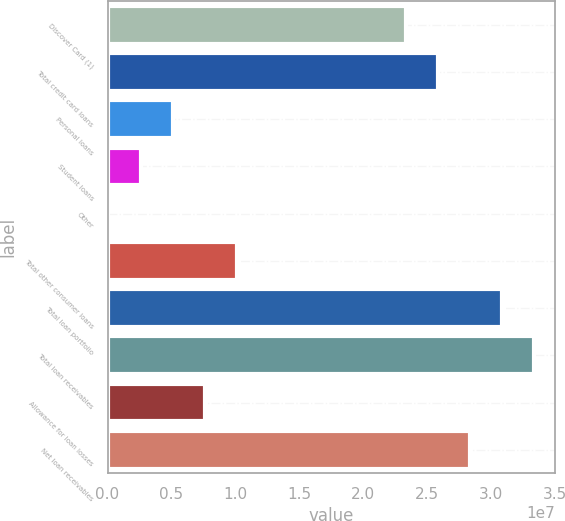Convert chart. <chart><loc_0><loc_0><loc_500><loc_500><bar_chart><fcel>Discover Card (1)<fcel>Total credit card loans<fcel>Personal loans<fcel>Student loans<fcel>Other<fcel>Total other consumer loans<fcel>Total loan portfolio<fcel>Total loan receivables<fcel>Allowance for loan losses<fcel>Net loan receivables<nl><fcel>2.33481e+07<fcel>2.58624e+07<fcel>5.10275e+06<fcel>2.58851e+06<fcel>74282<fcel>1.01312e+07<fcel>3.08908e+07<fcel>3.34051e+07<fcel>7.61698e+06<fcel>2.83766e+07<nl></chart> 